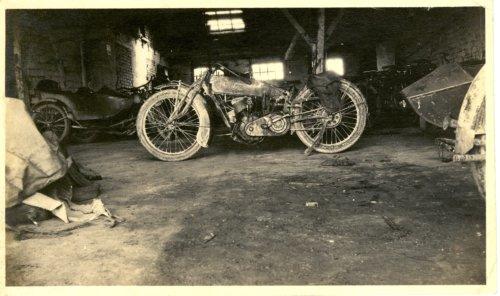Is the bike old?
Short answer required. Yes. Is the bike being rode on?
Give a very brief answer. No. Are other modes of transportation located in this building?
Give a very brief answer. Yes. 